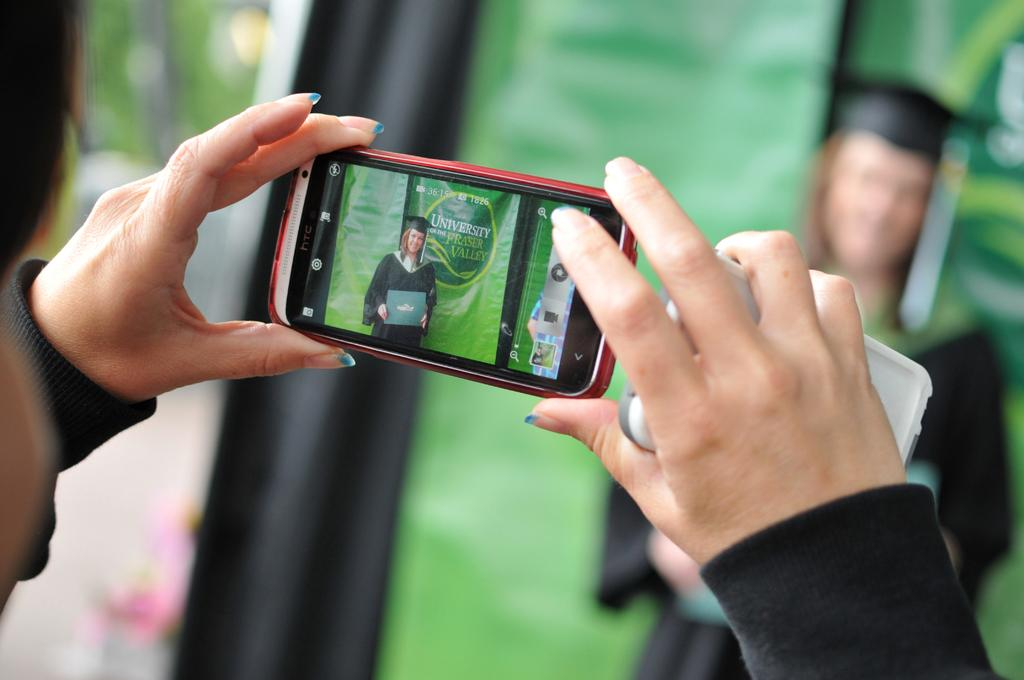Provide a one-sentence caption for the provided image. A man is taking a picture of a graduate from University of Frasier Valley. 